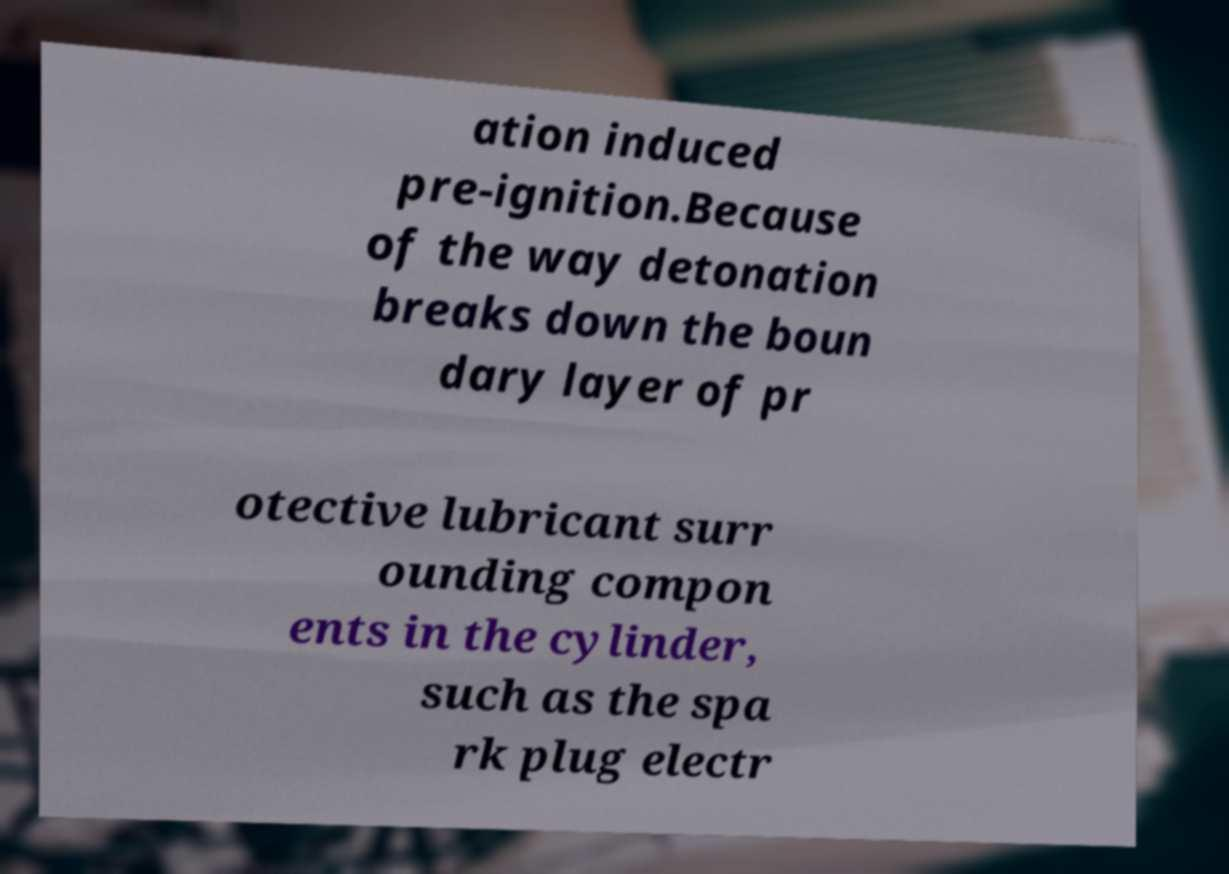What messages or text are displayed in this image? I need them in a readable, typed format. ation induced pre-ignition.Because of the way detonation breaks down the boun dary layer of pr otective lubricant surr ounding compon ents in the cylinder, such as the spa rk plug electr 